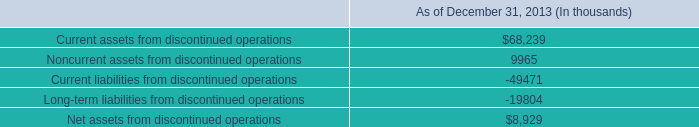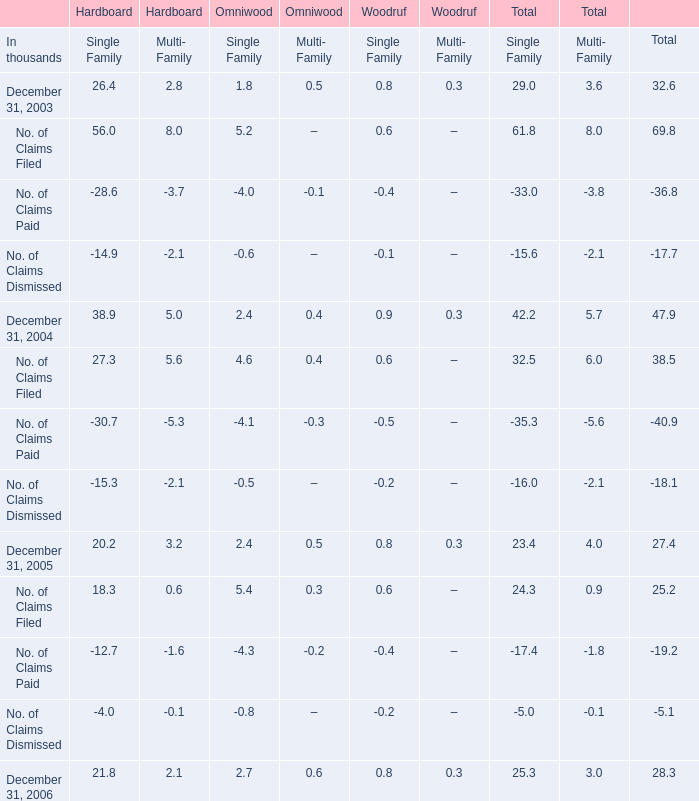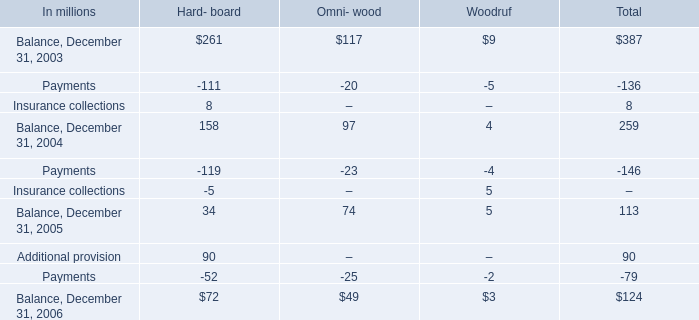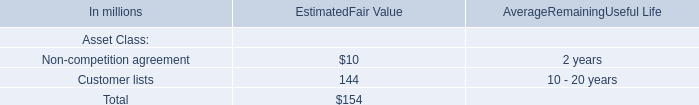What do all Hard- board sum up, excluding those negative ones in 2003? (in million) 
Computations: (261 + 8)
Answer: 269.0. 